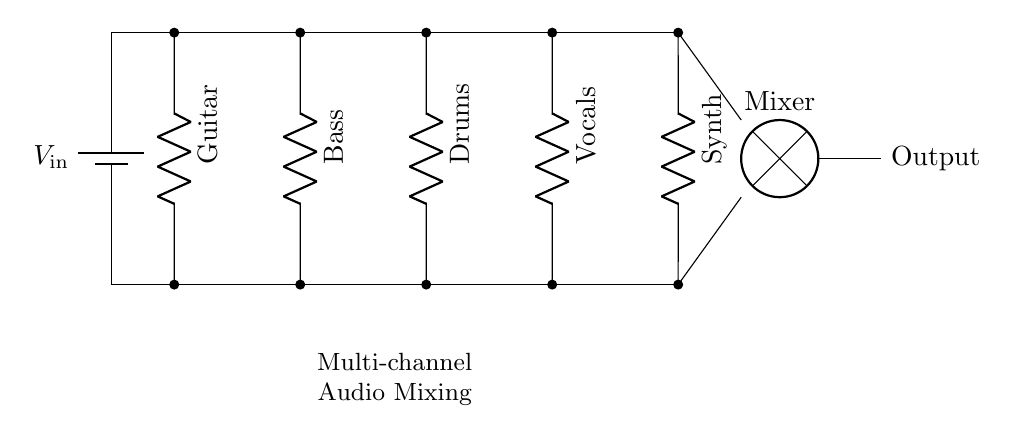What is the input voltage of the circuit? The input voltage is labeled as V_in in the circuit diagram, indicating the source voltage connected to the parallel components.
Answer: V_in How many channels are there for audio mixing? The circuit diagram shows five distinct components: Guitar, Bass, Drums, Vocals, and Synth, each representing a different audio channel.
Answer: Five Which component has the highest position in the diagram? The highest component in the diagram is the Guitar, which is the first element connected in the parallel setup at the top.
Answer: Guitar What type of circuit is represented in the diagram? The circuit is identified as a parallel circuit because the components are arranged side by side and share the same input voltage while having their individual paths.
Answer: Parallel If one channel is disconnected, how will it affect the others? In a parallel circuit, if one channel is disconnected, it does not affect the other channels because each operates independently with the same input voltage.
Answer: No effect Which component is the last in the parallel arrangement? The last component connected in the parallel circuit is the Synth, positioned at the far right of the circuit diagram.
Answer: Synth What connects all the components together at the bottom? The components are connected together at the bottom by a single wire, which leads to the input of the mixer, creating a common return path for the circuit.
Answer: Common wire 